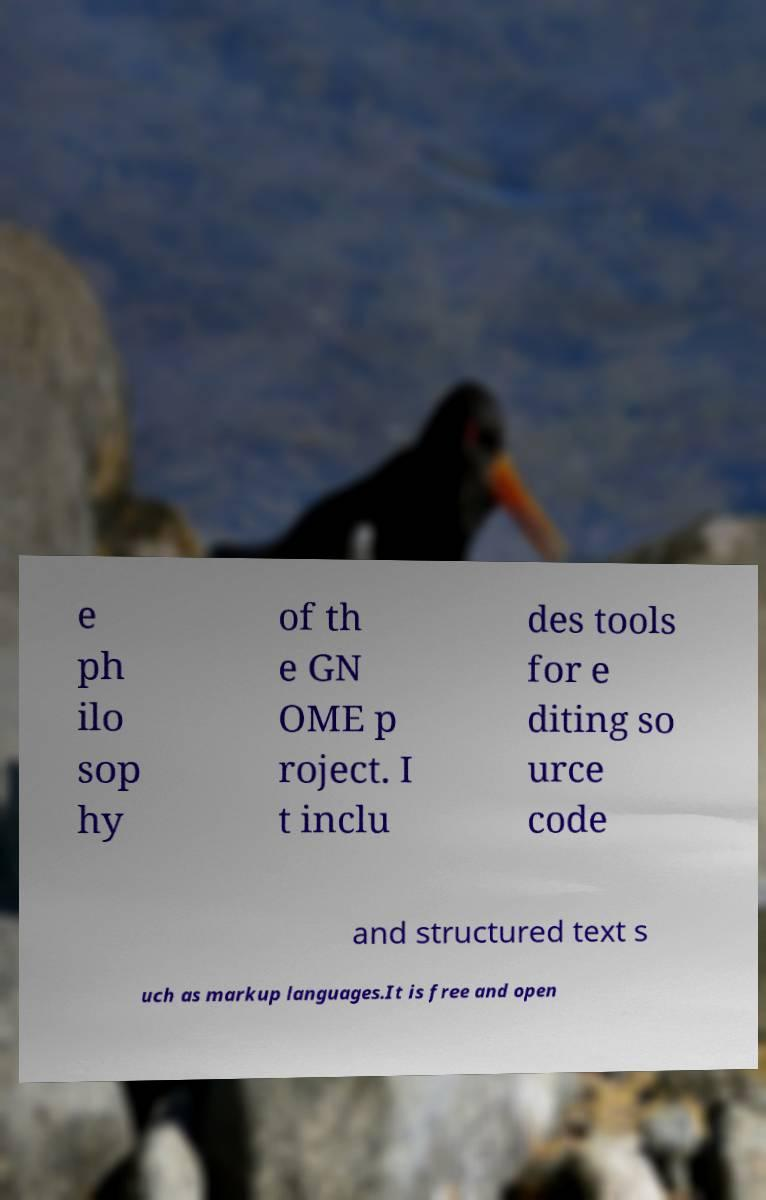Could you assist in decoding the text presented in this image and type it out clearly? e ph ilo sop hy of th e GN OME p roject. I t inclu des tools for e diting so urce code and structured text s uch as markup languages.It is free and open 